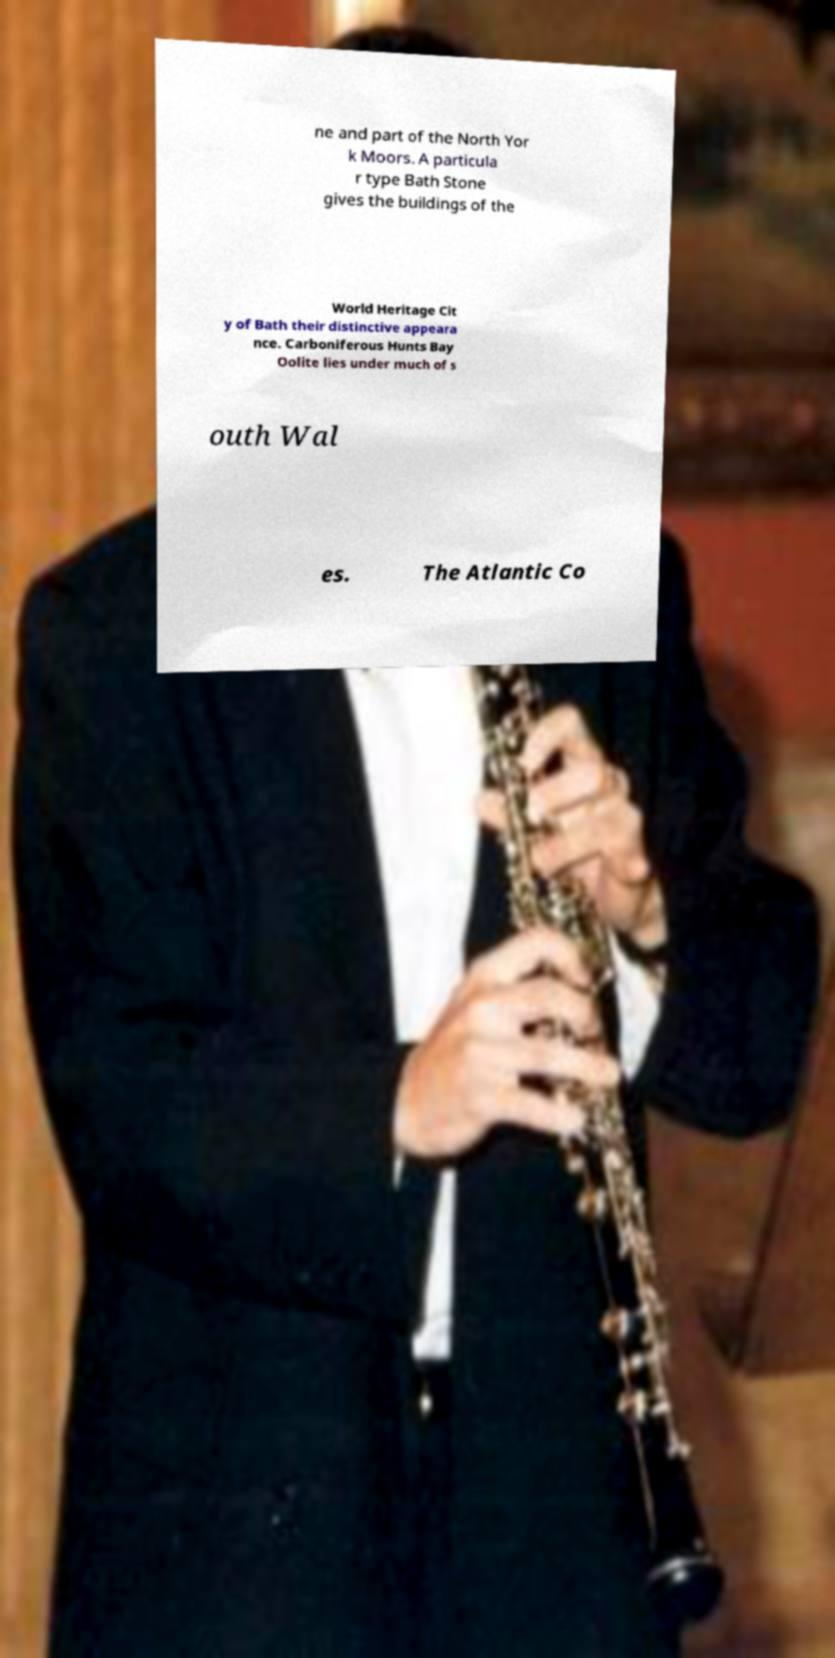Could you extract and type out the text from this image? ne and part of the North Yor k Moors. A particula r type Bath Stone gives the buildings of the World Heritage Cit y of Bath their distinctive appeara nce. Carboniferous Hunts Bay Oolite lies under much of s outh Wal es. The Atlantic Co 